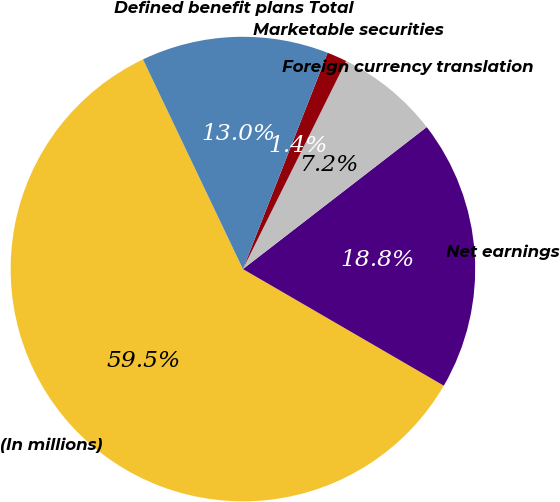Convert chart. <chart><loc_0><loc_0><loc_500><loc_500><pie_chart><fcel>(In millions)<fcel>Net earnings<fcel>Foreign currency translation<fcel>Marketable securities<fcel>Defined benefit plans Total<nl><fcel>59.55%<fcel>18.84%<fcel>7.2%<fcel>1.39%<fcel>13.02%<nl></chart> 